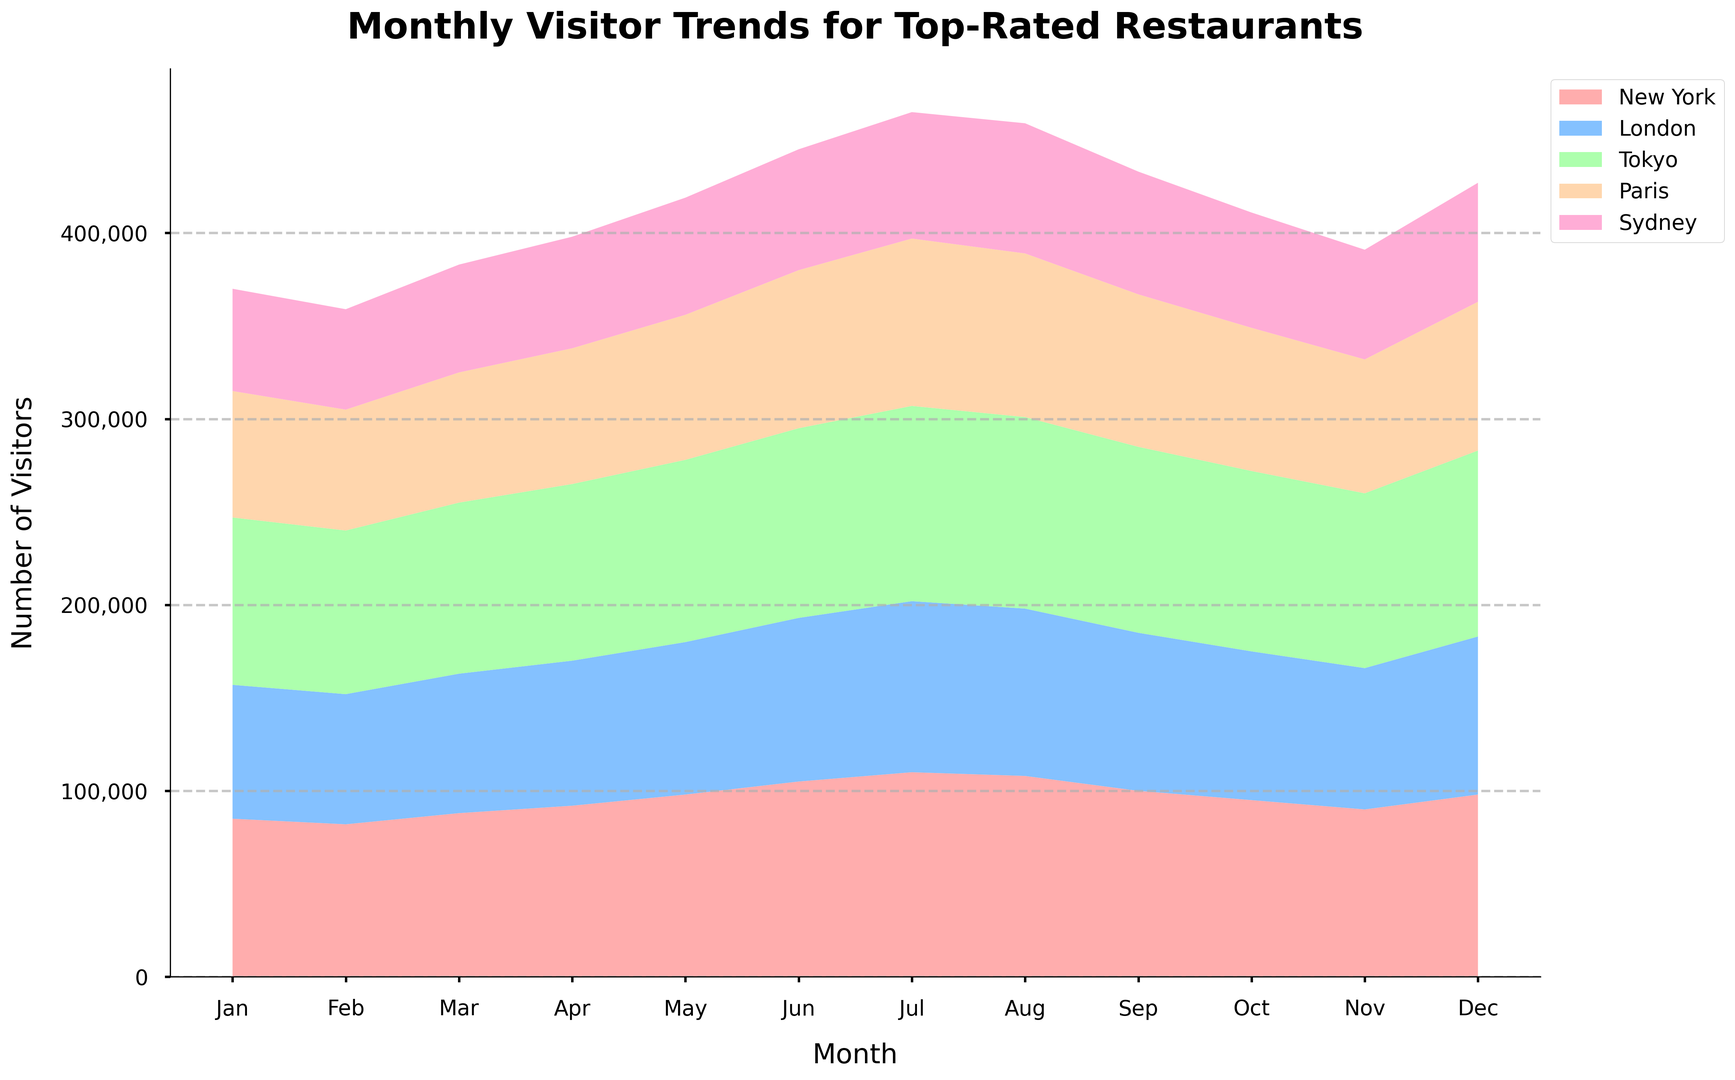What is the total number of visitors across all cities in June? To find the total number of visitors across all cities in June, we sum the number of visitors for each city: New York (105,000) + London (88,000) + Tokyo (102,000) + Paris (85,000) + Sydney (65,000). Therefore, the total is 105,000 + 88,000 + 102,000 + 85,000 + 65,000 = 445,000.
Answer: 445,000 Which city received the highest number of visitors in July? To determine which city had the highest number of visitors in July, we compare the visitor counts for each city. New York had 110,000, London had 92,000, Tokyo had 105,000, Paris had 90,000, and Sydney had 68,000. New York had the highest number of visitors in July with 110,000.
Answer: New York How does the number of visitors in Paris in August compare to the number of visitors in Sydney in August? In August, Paris had 88,000 visitors while Sydney had 70,000 visitors. Comparing the two, Paris had more visitors than Sydney.
Answer: Paris had more visitors What is the average number of visitors across all cities in December? To find the average, we sum the number of visitors for each city in December: New York (98,000) + London (85,000) + Tokyo (100,000) + Paris (80,000) + Sydney (64,000), giving us a total of 427,000. The average is then 427,000 divided by 5, which equals 85,400.
Answer: 85,400 Between which two months did Tokyo see the largest increase in visitors? By comparing the visitor numbers month-to-month for Tokyo, we find the largest increase occurs between June (102,000) and July (105,000). The increase is 105,000 - 102,000 = 3,000. This is the largest month-to-month increase for Tokyo throughout the year.
Answer: June to July Which city had the lowest number of visitors in February? To find the city with the lowest number of visitors in February, we check the visitor counts: New York (82,000), London (70,000), Tokyo (88,000), Paris (65,000), and Sydney (54,000). The city with the lowest number of visitors is Sydney with 54,000 visitors.
Answer: Sydney What is the total difference in the number of visitors between January and October in New York? In January, New York had 85,000 visitors and in October, it had 95,000 visitors. The total difference is 95,000 - 85,000 = 10,000 visitors.
Answer: 10,000 In which month did Sydney receive exactly 70,000 visitors? Sydney received exactly 70,000 visitors in August.
Answer: August 